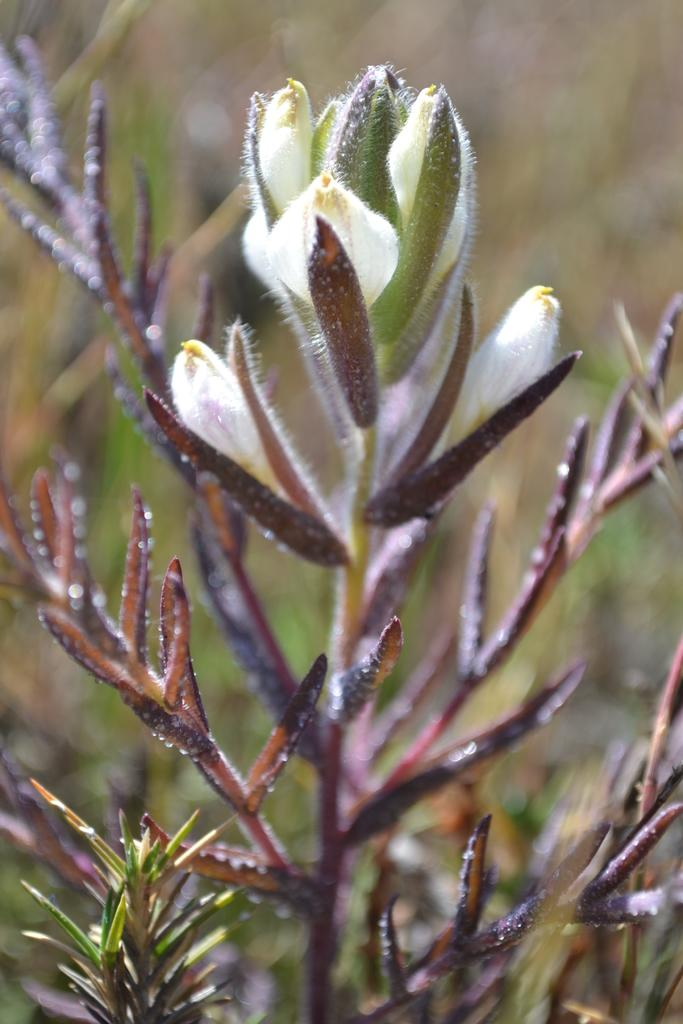What types of living organisms can be seen in the image? Plants and flowers are visible in the image. Can you describe the appearance of the flowers? The flowers are colorful and appear to be in bloom. What is the condition of the background in the image? The background of the image is blurred. How many bears can be seen playing with the pig in the image? There are no bears or pigs present in the image; it features plants and flowers. 